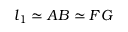Convert formula to latex. <formula><loc_0><loc_0><loc_500><loc_500>l _ { 1 } \simeq A B \simeq F G</formula> 